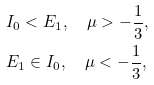<formula> <loc_0><loc_0><loc_500><loc_500>& I _ { 0 } < E _ { 1 } , \quad \mu > - \frac { 1 } { 3 } , \\ & E _ { 1 } \in I _ { 0 } , \quad \mu < - \frac { 1 } { 3 } ,</formula> 